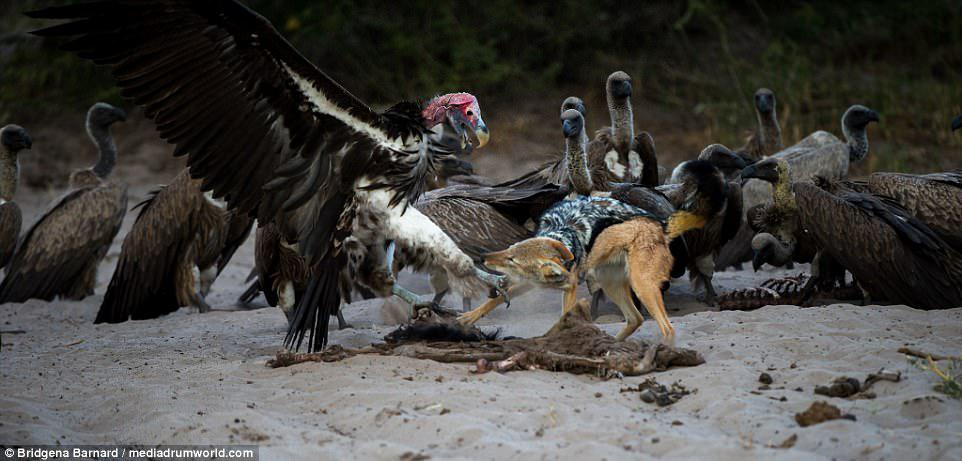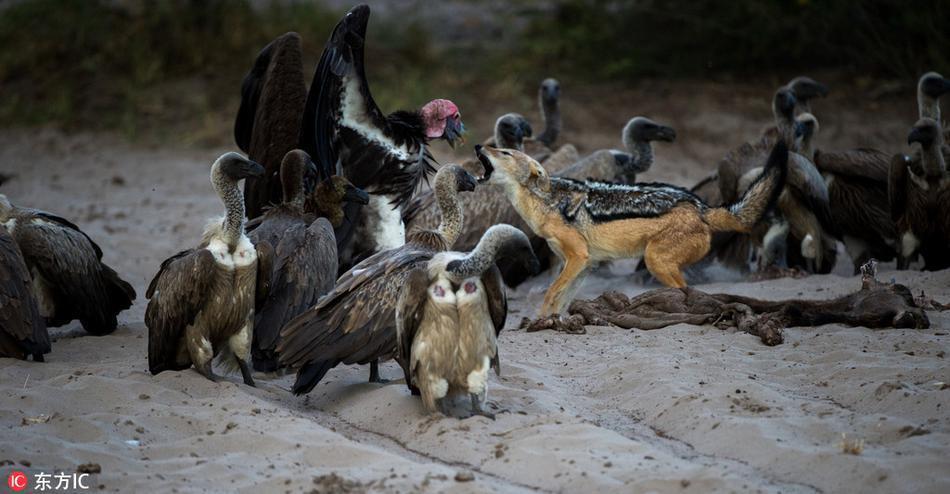The first image is the image on the left, the second image is the image on the right. For the images shown, is this caption "There is a group of at least 5 vultures in the right image." true? Answer yes or no. Yes. The first image is the image on the left, the second image is the image on the right. For the images displayed, is the sentence "Three or more vultures perched on a branch are visible." factually correct? Answer yes or no. No. 